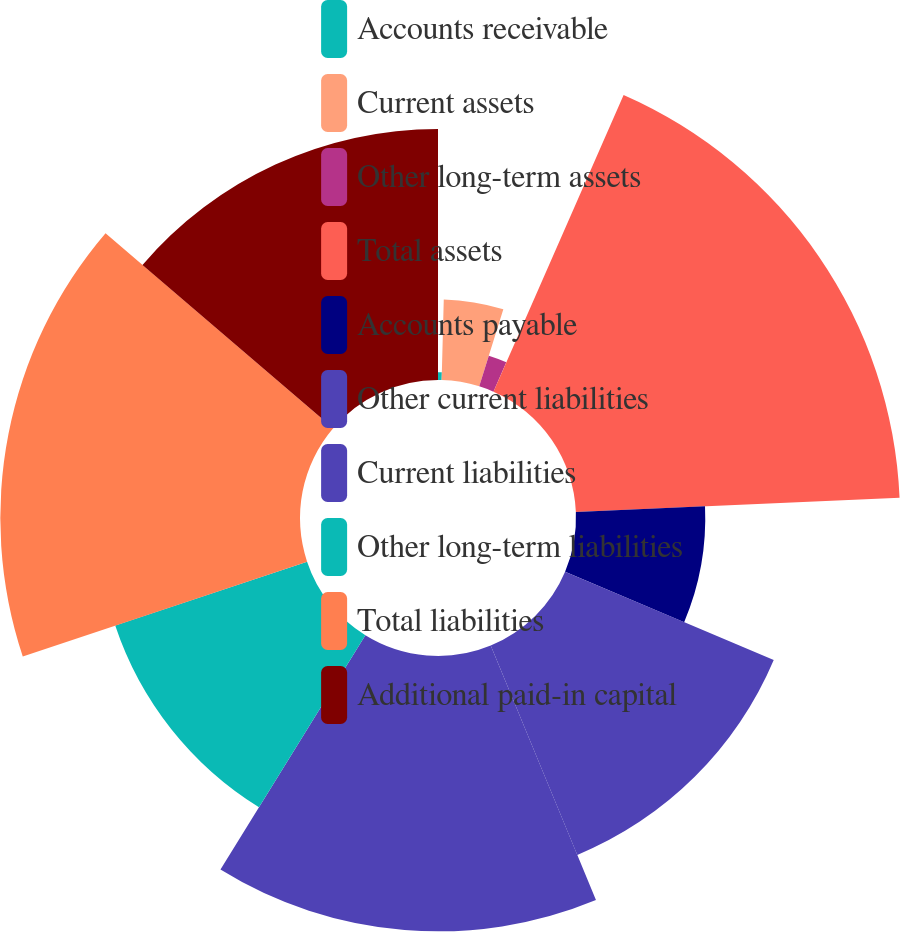Convert chart. <chart><loc_0><loc_0><loc_500><loc_500><pie_chart><fcel>Accounts receivable<fcel>Current assets<fcel>Other long-term assets<fcel>Total assets<fcel>Accounts payable<fcel>Other current liabilities<fcel>Current liabilities<fcel>Other long-term liabilities<fcel>Total liabilities<fcel>Additional paid-in capital<nl><fcel>0.42%<fcel>4.41%<fcel>1.75%<fcel>17.72%<fcel>7.07%<fcel>12.39%<fcel>15.06%<fcel>11.06%<fcel>16.39%<fcel>13.73%<nl></chart> 